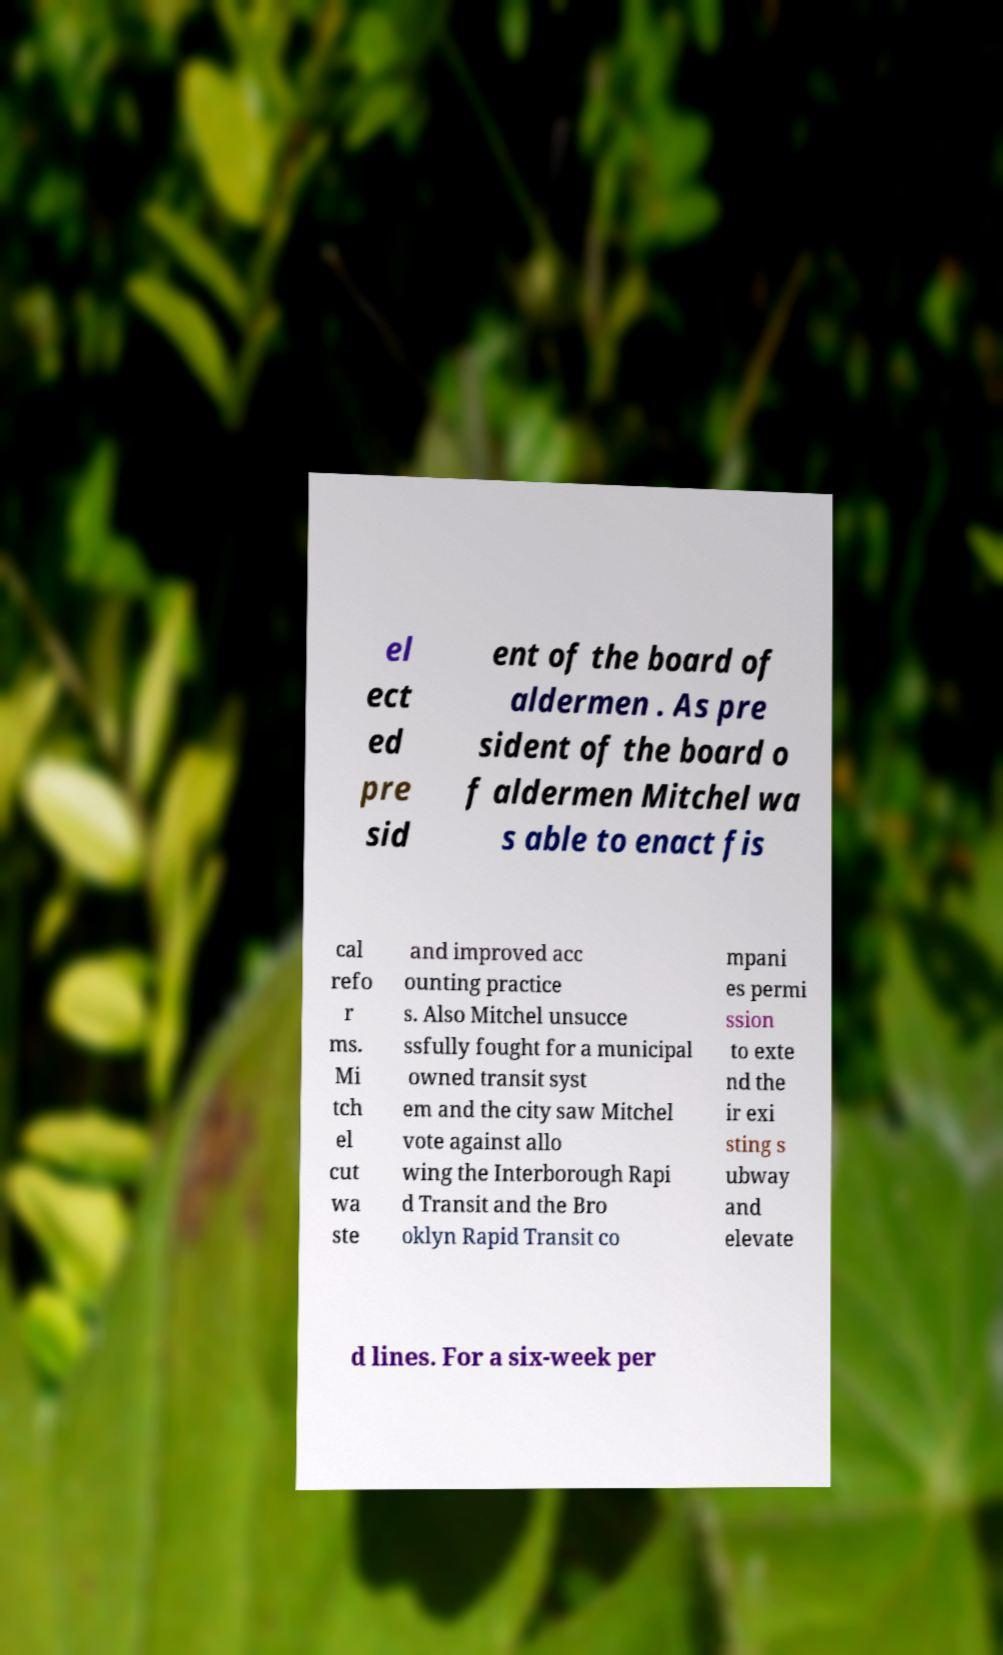There's text embedded in this image that I need extracted. Can you transcribe it verbatim? el ect ed pre sid ent of the board of aldermen . As pre sident of the board o f aldermen Mitchel wa s able to enact fis cal refo r ms. Mi tch el cut wa ste and improved acc ounting practice s. Also Mitchel unsucce ssfully fought for a municipal owned transit syst em and the city saw Mitchel vote against allo wing the Interborough Rapi d Transit and the Bro oklyn Rapid Transit co mpani es permi ssion to exte nd the ir exi sting s ubway and elevate d lines. For a six-week per 